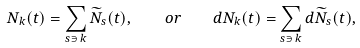Convert formula to latex. <formula><loc_0><loc_0><loc_500><loc_500>N _ { k } ( t ) = \sum _ { s \ni \, k } \widetilde { N } _ { s } ( t ) , \quad o r \quad d N _ { k } ( t ) = \sum _ { s \ni \, k } d \widetilde { N } _ { s } ( t ) ,</formula> 